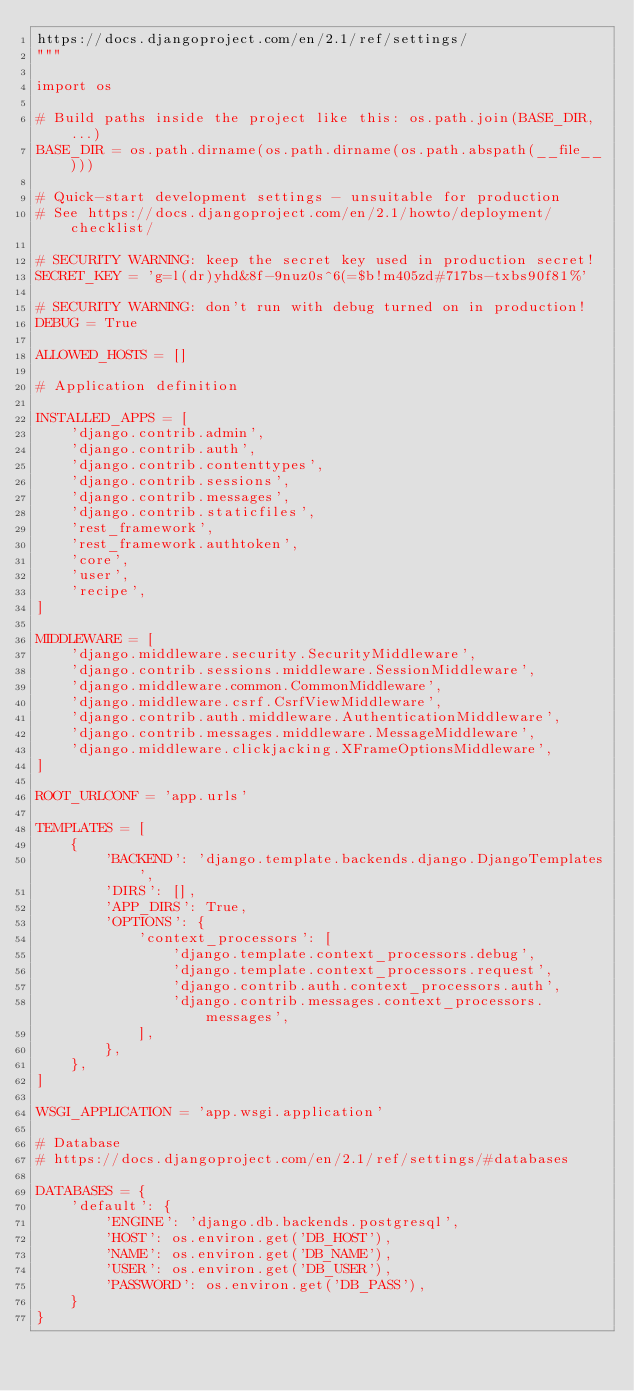<code> <loc_0><loc_0><loc_500><loc_500><_Python_>https://docs.djangoproject.com/en/2.1/ref/settings/
"""

import os

# Build paths inside the project like this: os.path.join(BASE_DIR, ...)
BASE_DIR = os.path.dirname(os.path.dirname(os.path.abspath(__file__)))

# Quick-start development settings - unsuitable for production
# See https://docs.djangoproject.com/en/2.1/howto/deployment/checklist/

# SECURITY WARNING: keep the secret key used in production secret!
SECRET_KEY = 'g=l(dr)yhd&8f-9nuz0s^6(=$b!m405zd#717bs-txbs90f81%'

# SECURITY WARNING: don't run with debug turned on in production!
DEBUG = True

ALLOWED_HOSTS = []

# Application definition

INSTALLED_APPS = [
    'django.contrib.admin',
    'django.contrib.auth',
    'django.contrib.contenttypes',
    'django.contrib.sessions',
    'django.contrib.messages',
    'django.contrib.staticfiles',
    'rest_framework',
    'rest_framework.authtoken',
    'core',
    'user',
    'recipe',
]

MIDDLEWARE = [
    'django.middleware.security.SecurityMiddleware',
    'django.contrib.sessions.middleware.SessionMiddleware',
    'django.middleware.common.CommonMiddleware',
    'django.middleware.csrf.CsrfViewMiddleware',
    'django.contrib.auth.middleware.AuthenticationMiddleware',
    'django.contrib.messages.middleware.MessageMiddleware',
    'django.middleware.clickjacking.XFrameOptionsMiddleware',
]

ROOT_URLCONF = 'app.urls'

TEMPLATES = [
    {
        'BACKEND': 'django.template.backends.django.DjangoTemplates',
        'DIRS': [],
        'APP_DIRS': True,
        'OPTIONS': {
            'context_processors': [
                'django.template.context_processors.debug',
                'django.template.context_processors.request',
                'django.contrib.auth.context_processors.auth',
                'django.contrib.messages.context_processors.messages',
            ],
        },
    },
]

WSGI_APPLICATION = 'app.wsgi.application'

# Database
# https://docs.djangoproject.com/en/2.1/ref/settings/#databases

DATABASES = {
    'default': {
        'ENGINE': 'django.db.backends.postgresql',
        'HOST': os.environ.get('DB_HOST'),
        'NAME': os.environ.get('DB_NAME'),
        'USER': os.environ.get('DB_USER'),
        'PASSWORD': os.environ.get('DB_PASS'),
    }
}
</code> 